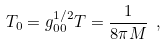<formula> <loc_0><loc_0><loc_500><loc_500>T _ { 0 } = g _ { 0 0 } ^ { 1 / 2 } T = \frac { 1 } { 8 \pi { M } } \ ,</formula> 